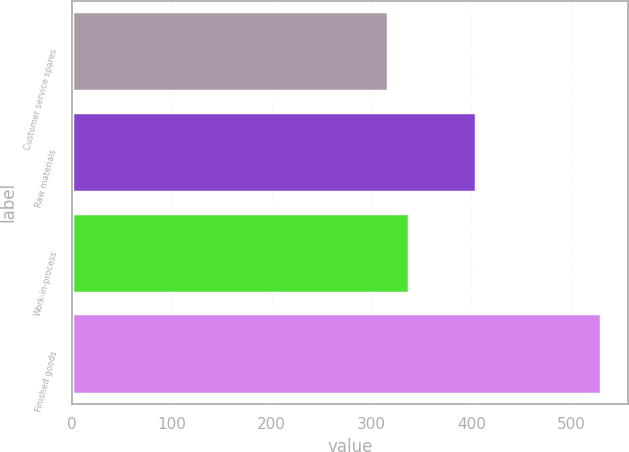Convert chart. <chart><loc_0><loc_0><loc_500><loc_500><bar_chart><fcel>Customer service spares<fcel>Raw materials<fcel>Work-in-process<fcel>Finished goods<nl><fcel>316<fcel>405<fcel>337.4<fcel>530<nl></chart> 